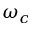Convert formula to latex. <formula><loc_0><loc_0><loc_500><loc_500>\omega _ { c }</formula> 